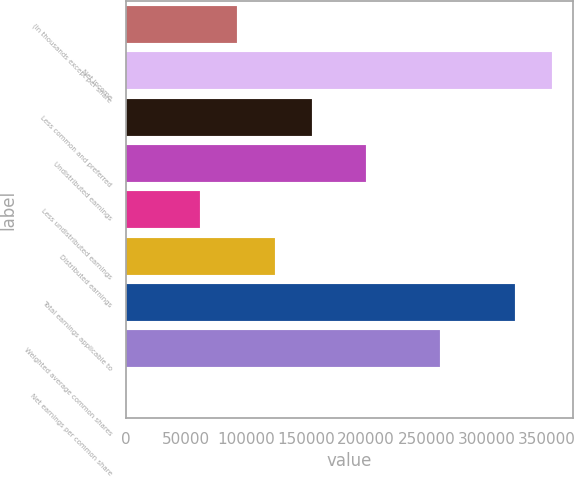Convert chart. <chart><loc_0><loc_0><loc_500><loc_500><bar_chart><fcel>(In thousands except per share<fcel>Net income<fcel>Less common and preferred<fcel>Undistributed earnings<fcel>Less undistributed earnings<fcel>Distributed earnings<fcel>Total earnings applicable to<fcel>Weighted average common shares<fcel>Net earnings per common share<nl><fcel>92842.1<fcel>354380<fcel>154736<fcel>199645<fcel>61895.2<fcel>123789<fcel>323433<fcel>261539<fcel>1.2<nl></chart> 